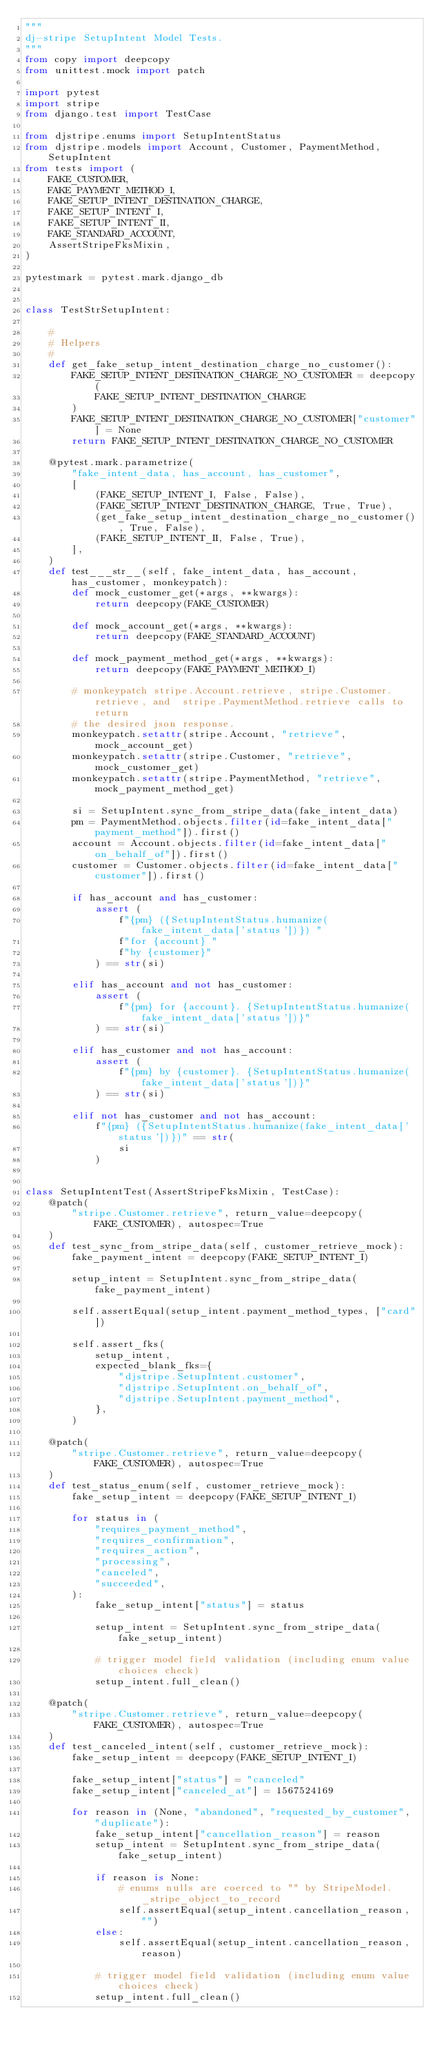<code> <loc_0><loc_0><loc_500><loc_500><_Python_>"""
dj-stripe SetupIntent Model Tests.
"""
from copy import deepcopy
from unittest.mock import patch

import pytest
import stripe
from django.test import TestCase

from djstripe.enums import SetupIntentStatus
from djstripe.models import Account, Customer, PaymentMethod, SetupIntent
from tests import (
    FAKE_CUSTOMER,
    FAKE_PAYMENT_METHOD_I,
    FAKE_SETUP_INTENT_DESTINATION_CHARGE,
    FAKE_SETUP_INTENT_I,
    FAKE_SETUP_INTENT_II,
    FAKE_STANDARD_ACCOUNT,
    AssertStripeFksMixin,
)

pytestmark = pytest.mark.django_db


class TestStrSetupIntent:

    #
    # Helpers
    #
    def get_fake_setup_intent_destination_charge_no_customer():
        FAKE_SETUP_INTENT_DESTINATION_CHARGE_NO_CUSTOMER = deepcopy(
            FAKE_SETUP_INTENT_DESTINATION_CHARGE
        )
        FAKE_SETUP_INTENT_DESTINATION_CHARGE_NO_CUSTOMER["customer"] = None
        return FAKE_SETUP_INTENT_DESTINATION_CHARGE_NO_CUSTOMER

    @pytest.mark.parametrize(
        "fake_intent_data, has_account, has_customer",
        [
            (FAKE_SETUP_INTENT_I, False, False),
            (FAKE_SETUP_INTENT_DESTINATION_CHARGE, True, True),
            (get_fake_setup_intent_destination_charge_no_customer(), True, False),
            (FAKE_SETUP_INTENT_II, False, True),
        ],
    )
    def test___str__(self, fake_intent_data, has_account, has_customer, monkeypatch):
        def mock_customer_get(*args, **kwargs):
            return deepcopy(FAKE_CUSTOMER)

        def mock_account_get(*args, **kwargs):
            return deepcopy(FAKE_STANDARD_ACCOUNT)

        def mock_payment_method_get(*args, **kwargs):
            return deepcopy(FAKE_PAYMENT_METHOD_I)

        # monkeypatch stripe.Account.retrieve, stripe.Customer.retrieve, and  stripe.PaymentMethod.retrieve calls to return
        # the desired json response.
        monkeypatch.setattr(stripe.Account, "retrieve", mock_account_get)
        monkeypatch.setattr(stripe.Customer, "retrieve", mock_customer_get)
        monkeypatch.setattr(stripe.PaymentMethod, "retrieve", mock_payment_method_get)

        si = SetupIntent.sync_from_stripe_data(fake_intent_data)
        pm = PaymentMethod.objects.filter(id=fake_intent_data["payment_method"]).first()
        account = Account.objects.filter(id=fake_intent_data["on_behalf_of"]).first()
        customer = Customer.objects.filter(id=fake_intent_data["customer"]).first()

        if has_account and has_customer:
            assert (
                f"{pm} ({SetupIntentStatus.humanize(fake_intent_data['status'])}) "
                f"for {account} "
                f"by {customer}"
            ) == str(si)

        elif has_account and not has_customer:
            assert (
                f"{pm} for {account}. {SetupIntentStatus.humanize(fake_intent_data['status'])}"
            ) == str(si)

        elif has_customer and not has_account:
            assert (
                f"{pm} by {customer}. {SetupIntentStatus.humanize(fake_intent_data['status'])}"
            ) == str(si)

        elif not has_customer and not has_account:
            f"{pm} ({SetupIntentStatus.humanize(fake_intent_data['status'])})" == str(
                si
            )


class SetupIntentTest(AssertStripeFksMixin, TestCase):
    @patch(
        "stripe.Customer.retrieve", return_value=deepcopy(FAKE_CUSTOMER), autospec=True
    )
    def test_sync_from_stripe_data(self, customer_retrieve_mock):
        fake_payment_intent = deepcopy(FAKE_SETUP_INTENT_I)

        setup_intent = SetupIntent.sync_from_stripe_data(fake_payment_intent)

        self.assertEqual(setup_intent.payment_method_types, ["card"])

        self.assert_fks(
            setup_intent,
            expected_blank_fks={
                "djstripe.SetupIntent.customer",
                "djstripe.SetupIntent.on_behalf_of",
                "djstripe.SetupIntent.payment_method",
            },
        )

    @patch(
        "stripe.Customer.retrieve", return_value=deepcopy(FAKE_CUSTOMER), autospec=True
    )
    def test_status_enum(self, customer_retrieve_mock):
        fake_setup_intent = deepcopy(FAKE_SETUP_INTENT_I)

        for status in (
            "requires_payment_method",
            "requires_confirmation",
            "requires_action",
            "processing",
            "canceled",
            "succeeded",
        ):
            fake_setup_intent["status"] = status

            setup_intent = SetupIntent.sync_from_stripe_data(fake_setup_intent)

            # trigger model field validation (including enum value choices check)
            setup_intent.full_clean()

    @patch(
        "stripe.Customer.retrieve", return_value=deepcopy(FAKE_CUSTOMER), autospec=True
    )
    def test_canceled_intent(self, customer_retrieve_mock):
        fake_setup_intent = deepcopy(FAKE_SETUP_INTENT_I)

        fake_setup_intent["status"] = "canceled"
        fake_setup_intent["canceled_at"] = 1567524169

        for reason in (None, "abandoned", "requested_by_customer", "duplicate"):
            fake_setup_intent["cancellation_reason"] = reason
            setup_intent = SetupIntent.sync_from_stripe_data(fake_setup_intent)

            if reason is None:
                # enums nulls are coerced to "" by StripeModel._stripe_object_to_record
                self.assertEqual(setup_intent.cancellation_reason, "")
            else:
                self.assertEqual(setup_intent.cancellation_reason, reason)

            # trigger model field validation (including enum value choices check)
            setup_intent.full_clean()
</code> 